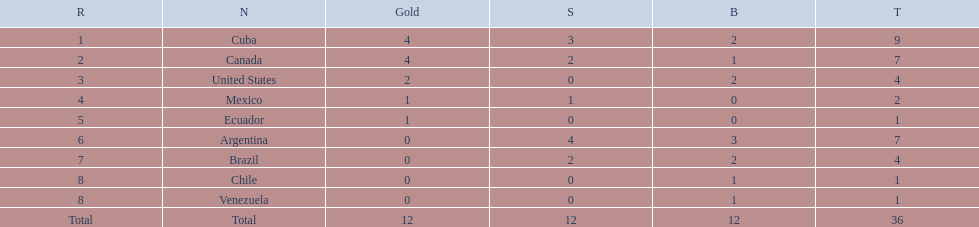What were all of the nations involved in the canoeing at the 2011 pan american games? Cuba, Canada, United States, Mexico, Ecuador, Argentina, Brazil, Chile, Venezuela, Total. Of these, which had a numbered rank? Cuba, Canada, United States, Mexico, Ecuador, Argentina, Brazil, Chile, Venezuela. From these, which had the highest number of bronze? Argentina. Can you parse all the data within this table? {'header': ['R', 'N', 'Gold', 'S', 'B', 'T'], 'rows': [['1', 'Cuba', '4', '3', '2', '9'], ['2', 'Canada', '4', '2', '1', '7'], ['3', 'United States', '2', '0', '2', '4'], ['4', 'Mexico', '1', '1', '0', '2'], ['5', 'Ecuador', '1', '0', '0', '1'], ['6', 'Argentina', '0', '4', '3', '7'], ['7', 'Brazil', '0', '2', '2', '4'], ['8', 'Chile', '0', '0', '1', '1'], ['8', 'Venezuela', '0', '0', '1', '1'], ['Total', 'Total', '12', '12', '12', '36']]} 